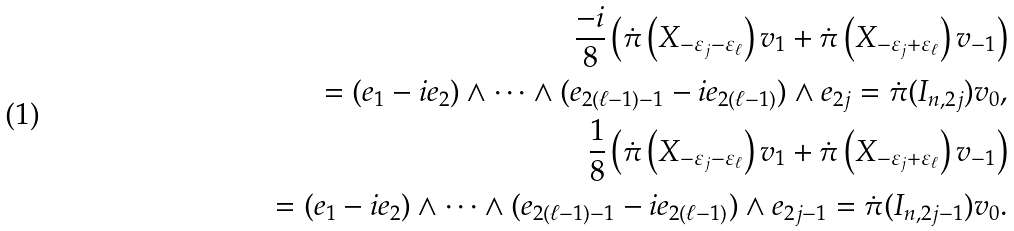Convert formula to latex. <formula><loc_0><loc_0><loc_500><loc_500>\frac { - i } { 8 } \left ( \dot { \pi } \left ( X _ { - \varepsilon _ { j } - \varepsilon _ { \ell } } \right ) v _ { 1 } + \dot { \pi } \left ( X _ { - \varepsilon _ { j } + \varepsilon _ { \ell } } \right ) v _ { - 1 } \right ) \\ \quad = ( { e } _ { 1 } - i { e } _ { 2 } ) \wedge \dots \wedge ( { e } _ { 2 ( \ell - 1 ) - 1 } - i { e } _ { 2 ( \ell - 1 ) } ) \wedge { e } _ { 2 j } = \dot { \pi } ( I _ { n , 2 j } ) v _ { 0 } , \\ \frac { 1 } { 8 } \left ( \dot { \pi } \left ( X _ { - \varepsilon _ { j } - \varepsilon _ { \ell } } \right ) v _ { 1 } + \dot { \pi } \left ( X _ { - \varepsilon _ { j } + \varepsilon _ { \ell } } \right ) v _ { - 1 } \right ) \\ \quad = ( { e } _ { 1 } - i { e } _ { 2 } ) \wedge \dots \wedge ( { e } _ { 2 ( \ell - 1 ) - 1 } - i { e } _ { 2 ( \ell - 1 ) } ) \wedge { e } _ { 2 j - 1 } = \dot { \pi } ( I _ { n , 2 j - 1 } ) v _ { 0 } .</formula> 